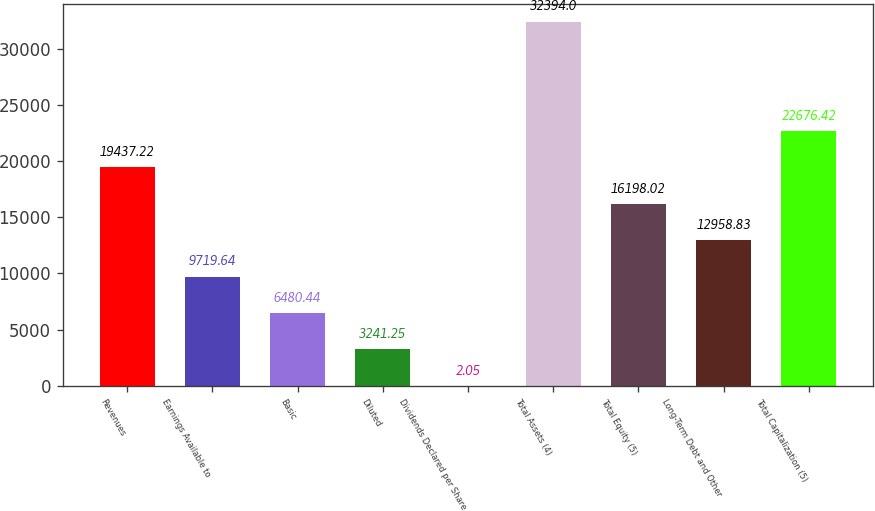<chart> <loc_0><loc_0><loc_500><loc_500><bar_chart><fcel>Revenues<fcel>Earnings Available to<fcel>Basic<fcel>Diluted<fcel>Dividends Declared per Share<fcel>Total Assets (4)<fcel>Total Equity (5)<fcel>Long-Term Debt and Other<fcel>Total Capitalization (5)<nl><fcel>19437.2<fcel>9719.64<fcel>6480.44<fcel>3241.25<fcel>2.05<fcel>32394<fcel>16198<fcel>12958.8<fcel>22676.4<nl></chart> 